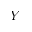<formula> <loc_0><loc_0><loc_500><loc_500>Y</formula> 